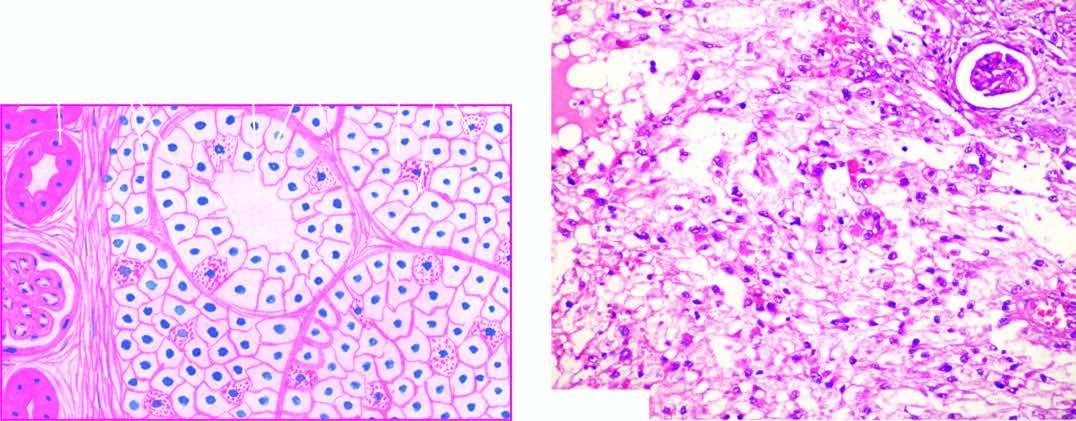do bone marrow in itp predominate in the tumour while the stroma is composed of fine and delicate fibrous tissue?
Answer the question using a single word or phrase. No 